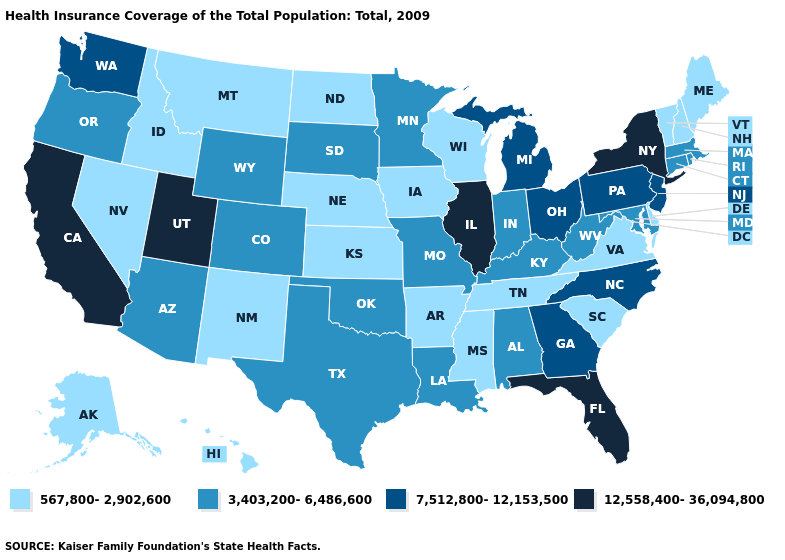Among the states that border Texas , which have the highest value?
Write a very short answer. Louisiana, Oklahoma. Among the states that border Kansas , does Colorado have the highest value?
Write a very short answer. Yes. Does Iowa have the highest value in the USA?
Keep it brief. No. Which states have the lowest value in the Northeast?
Quick response, please. Maine, New Hampshire, Vermont. What is the lowest value in states that border New York?
Concise answer only. 567,800-2,902,600. Name the states that have a value in the range 7,512,800-12,153,500?
Concise answer only. Georgia, Michigan, New Jersey, North Carolina, Ohio, Pennsylvania, Washington. What is the highest value in the South ?
Give a very brief answer. 12,558,400-36,094,800. Does New York have the highest value in the USA?
Concise answer only. Yes. What is the value of Wisconsin?
Concise answer only. 567,800-2,902,600. Which states hav the highest value in the MidWest?
Be succinct. Illinois. Name the states that have a value in the range 567,800-2,902,600?
Answer briefly. Alaska, Arkansas, Delaware, Hawaii, Idaho, Iowa, Kansas, Maine, Mississippi, Montana, Nebraska, Nevada, New Hampshire, New Mexico, North Dakota, South Carolina, Tennessee, Vermont, Virginia, Wisconsin. Name the states that have a value in the range 12,558,400-36,094,800?
Quick response, please. California, Florida, Illinois, New York, Utah. Name the states that have a value in the range 3,403,200-6,486,600?
Answer briefly. Alabama, Arizona, Colorado, Connecticut, Indiana, Kentucky, Louisiana, Maryland, Massachusetts, Minnesota, Missouri, Oklahoma, Oregon, Rhode Island, South Dakota, Texas, West Virginia, Wyoming. What is the value of Arkansas?
Be succinct. 567,800-2,902,600. 